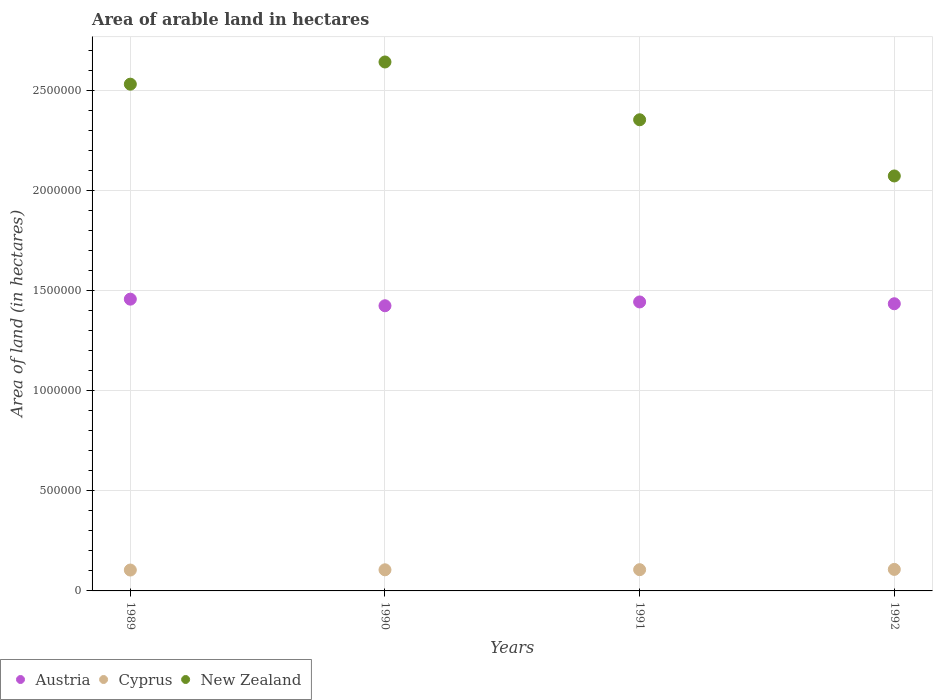What is the total arable land in New Zealand in 1990?
Provide a short and direct response. 2.64e+06. Across all years, what is the maximum total arable land in New Zealand?
Keep it short and to the point. 2.64e+06. Across all years, what is the minimum total arable land in Austria?
Your response must be concise. 1.43e+06. In which year was the total arable land in New Zealand minimum?
Your answer should be very brief. 1992. What is the total total arable land in New Zealand in the graph?
Keep it short and to the point. 9.61e+06. What is the difference between the total arable land in Cyprus in 1990 and that in 1991?
Your answer should be very brief. -600. What is the difference between the total arable land in Austria in 1992 and the total arable land in New Zealand in 1990?
Your response must be concise. -1.21e+06. What is the average total arable land in New Zealand per year?
Your answer should be compact. 2.40e+06. In the year 1991, what is the difference between the total arable land in Cyprus and total arable land in New Zealand?
Provide a succinct answer. -2.25e+06. What is the ratio of the total arable land in New Zealand in 1989 to that in 1990?
Make the answer very short. 0.96. Is the difference between the total arable land in Cyprus in 1991 and 1992 greater than the difference between the total arable land in New Zealand in 1991 and 1992?
Your response must be concise. No. What is the difference between the highest and the second highest total arable land in Austria?
Offer a terse response. 1.40e+04. What is the difference between the highest and the lowest total arable land in Cyprus?
Provide a short and direct response. 3200. In how many years, is the total arable land in Austria greater than the average total arable land in Austria taken over all years?
Offer a very short reply. 2. Is the sum of the total arable land in Cyprus in 1990 and 1992 greater than the maximum total arable land in Austria across all years?
Your answer should be very brief. No. Does the total arable land in Austria monotonically increase over the years?
Offer a very short reply. No. How many years are there in the graph?
Give a very brief answer. 4. Are the values on the major ticks of Y-axis written in scientific E-notation?
Provide a short and direct response. No. Does the graph contain grids?
Provide a succinct answer. Yes. Where does the legend appear in the graph?
Make the answer very short. Bottom left. What is the title of the graph?
Give a very brief answer. Area of arable land in hectares. What is the label or title of the X-axis?
Give a very brief answer. Years. What is the label or title of the Y-axis?
Provide a short and direct response. Area of land (in hectares). What is the Area of land (in hectares) in Austria in 1989?
Offer a terse response. 1.46e+06. What is the Area of land (in hectares) of Cyprus in 1989?
Offer a terse response. 1.04e+05. What is the Area of land (in hectares) of New Zealand in 1989?
Ensure brevity in your answer.  2.53e+06. What is the Area of land (in hectares) of Austria in 1990?
Provide a short and direct response. 1.43e+06. What is the Area of land (in hectares) in Cyprus in 1990?
Your answer should be compact. 1.06e+05. What is the Area of land (in hectares) of New Zealand in 1990?
Your answer should be compact. 2.64e+06. What is the Area of land (in hectares) of Austria in 1991?
Your answer should be compact. 1.44e+06. What is the Area of land (in hectares) in Cyprus in 1991?
Offer a very short reply. 1.06e+05. What is the Area of land (in hectares) in New Zealand in 1991?
Offer a terse response. 2.36e+06. What is the Area of land (in hectares) in Austria in 1992?
Provide a short and direct response. 1.44e+06. What is the Area of land (in hectares) of Cyprus in 1992?
Provide a short and direct response. 1.08e+05. What is the Area of land (in hectares) in New Zealand in 1992?
Make the answer very short. 2.08e+06. Across all years, what is the maximum Area of land (in hectares) of Austria?
Provide a short and direct response. 1.46e+06. Across all years, what is the maximum Area of land (in hectares) of Cyprus?
Your answer should be compact. 1.08e+05. Across all years, what is the maximum Area of land (in hectares) of New Zealand?
Offer a terse response. 2.64e+06. Across all years, what is the minimum Area of land (in hectares) of Austria?
Offer a very short reply. 1.43e+06. Across all years, what is the minimum Area of land (in hectares) of Cyprus?
Offer a very short reply. 1.04e+05. Across all years, what is the minimum Area of land (in hectares) in New Zealand?
Your response must be concise. 2.08e+06. What is the total Area of land (in hectares) in Austria in the graph?
Your answer should be compact. 5.77e+06. What is the total Area of land (in hectares) in Cyprus in the graph?
Provide a succinct answer. 4.24e+05. What is the total Area of land (in hectares) of New Zealand in the graph?
Your response must be concise. 9.61e+06. What is the difference between the Area of land (in hectares) of Austria in 1989 and that in 1990?
Provide a short and direct response. 3.30e+04. What is the difference between the Area of land (in hectares) in Cyprus in 1989 and that in 1990?
Provide a succinct answer. -1200. What is the difference between the Area of land (in hectares) of New Zealand in 1989 and that in 1990?
Your response must be concise. -1.11e+05. What is the difference between the Area of land (in hectares) in Austria in 1989 and that in 1991?
Keep it short and to the point. 1.40e+04. What is the difference between the Area of land (in hectares) in Cyprus in 1989 and that in 1991?
Your response must be concise. -1800. What is the difference between the Area of land (in hectares) of New Zealand in 1989 and that in 1991?
Your answer should be very brief. 1.78e+05. What is the difference between the Area of land (in hectares) of Austria in 1989 and that in 1992?
Make the answer very short. 2.30e+04. What is the difference between the Area of land (in hectares) in Cyprus in 1989 and that in 1992?
Your answer should be very brief. -3200. What is the difference between the Area of land (in hectares) of New Zealand in 1989 and that in 1992?
Provide a succinct answer. 4.59e+05. What is the difference between the Area of land (in hectares) of Austria in 1990 and that in 1991?
Your answer should be very brief. -1.90e+04. What is the difference between the Area of land (in hectares) of Cyprus in 1990 and that in 1991?
Your response must be concise. -600. What is the difference between the Area of land (in hectares) in New Zealand in 1990 and that in 1991?
Ensure brevity in your answer.  2.89e+05. What is the difference between the Area of land (in hectares) of Cyprus in 1990 and that in 1992?
Your answer should be compact. -2000. What is the difference between the Area of land (in hectares) of New Zealand in 1990 and that in 1992?
Ensure brevity in your answer.  5.70e+05. What is the difference between the Area of land (in hectares) of Austria in 1991 and that in 1992?
Keep it short and to the point. 9000. What is the difference between the Area of land (in hectares) in Cyprus in 1991 and that in 1992?
Give a very brief answer. -1400. What is the difference between the Area of land (in hectares) in New Zealand in 1991 and that in 1992?
Keep it short and to the point. 2.81e+05. What is the difference between the Area of land (in hectares) of Austria in 1989 and the Area of land (in hectares) of Cyprus in 1990?
Provide a succinct answer. 1.35e+06. What is the difference between the Area of land (in hectares) of Austria in 1989 and the Area of land (in hectares) of New Zealand in 1990?
Give a very brief answer. -1.19e+06. What is the difference between the Area of land (in hectares) of Cyprus in 1989 and the Area of land (in hectares) of New Zealand in 1990?
Your response must be concise. -2.54e+06. What is the difference between the Area of land (in hectares) of Austria in 1989 and the Area of land (in hectares) of Cyprus in 1991?
Keep it short and to the point. 1.35e+06. What is the difference between the Area of land (in hectares) of Austria in 1989 and the Area of land (in hectares) of New Zealand in 1991?
Your response must be concise. -8.97e+05. What is the difference between the Area of land (in hectares) of Cyprus in 1989 and the Area of land (in hectares) of New Zealand in 1991?
Offer a terse response. -2.25e+06. What is the difference between the Area of land (in hectares) in Austria in 1989 and the Area of land (in hectares) in Cyprus in 1992?
Give a very brief answer. 1.35e+06. What is the difference between the Area of land (in hectares) of Austria in 1989 and the Area of land (in hectares) of New Zealand in 1992?
Make the answer very short. -6.16e+05. What is the difference between the Area of land (in hectares) of Cyprus in 1989 and the Area of land (in hectares) of New Zealand in 1992?
Your answer should be very brief. -1.97e+06. What is the difference between the Area of land (in hectares) of Austria in 1990 and the Area of land (in hectares) of Cyprus in 1991?
Provide a succinct answer. 1.32e+06. What is the difference between the Area of land (in hectares) in Austria in 1990 and the Area of land (in hectares) in New Zealand in 1991?
Provide a short and direct response. -9.30e+05. What is the difference between the Area of land (in hectares) in Cyprus in 1990 and the Area of land (in hectares) in New Zealand in 1991?
Keep it short and to the point. -2.25e+06. What is the difference between the Area of land (in hectares) of Austria in 1990 and the Area of land (in hectares) of Cyprus in 1992?
Offer a terse response. 1.32e+06. What is the difference between the Area of land (in hectares) in Austria in 1990 and the Area of land (in hectares) in New Zealand in 1992?
Keep it short and to the point. -6.49e+05. What is the difference between the Area of land (in hectares) of Cyprus in 1990 and the Area of land (in hectares) of New Zealand in 1992?
Your answer should be compact. -1.97e+06. What is the difference between the Area of land (in hectares) in Austria in 1991 and the Area of land (in hectares) in Cyprus in 1992?
Your response must be concise. 1.34e+06. What is the difference between the Area of land (in hectares) in Austria in 1991 and the Area of land (in hectares) in New Zealand in 1992?
Your answer should be compact. -6.30e+05. What is the difference between the Area of land (in hectares) in Cyprus in 1991 and the Area of land (in hectares) in New Zealand in 1992?
Offer a very short reply. -1.97e+06. What is the average Area of land (in hectares) of Austria per year?
Your response must be concise. 1.44e+06. What is the average Area of land (in hectares) in Cyprus per year?
Give a very brief answer. 1.06e+05. What is the average Area of land (in hectares) in New Zealand per year?
Offer a very short reply. 2.40e+06. In the year 1989, what is the difference between the Area of land (in hectares) in Austria and Area of land (in hectares) in Cyprus?
Provide a succinct answer. 1.35e+06. In the year 1989, what is the difference between the Area of land (in hectares) in Austria and Area of land (in hectares) in New Zealand?
Keep it short and to the point. -1.08e+06. In the year 1989, what is the difference between the Area of land (in hectares) of Cyprus and Area of land (in hectares) of New Zealand?
Give a very brief answer. -2.43e+06. In the year 1990, what is the difference between the Area of land (in hectares) in Austria and Area of land (in hectares) in Cyprus?
Offer a terse response. 1.32e+06. In the year 1990, what is the difference between the Area of land (in hectares) of Austria and Area of land (in hectares) of New Zealand?
Your response must be concise. -1.22e+06. In the year 1990, what is the difference between the Area of land (in hectares) of Cyprus and Area of land (in hectares) of New Zealand?
Make the answer very short. -2.54e+06. In the year 1991, what is the difference between the Area of land (in hectares) of Austria and Area of land (in hectares) of Cyprus?
Keep it short and to the point. 1.34e+06. In the year 1991, what is the difference between the Area of land (in hectares) of Austria and Area of land (in hectares) of New Zealand?
Offer a terse response. -9.11e+05. In the year 1991, what is the difference between the Area of land (in hectares) in Cyprus and Area of land (in hectares) in New Zealand?
Ensure brevity in your answer.  -2.25e+06. In the year 1992, what is the difference between the Area of land (in hectares) in Austria and Area of land (in hectares) in Cyprus?
Provide a short and direct response. 1.33e+06. In the year 1992, what is the difference between the Area of land (in hectares) of Austria and Area of land (in hectares) of New Zealand?
Your answer should be compact. -6.39e+05. In the year 1992, what is the difference between the Area of land (in hectares) in Cyprus and Area of land (in hectares) in New Zealand?
Make the answer very short. -1.97e+06. What is the ratio of the Area of land (in hectares) in Austria in 1989 to that in 1990?
Make the answer very short. 1.02. What is the ratio of the Area of land (in hectares) of New Zealand in 1989 to that in 1990?
Provide a short and direct response. 0.96. What is the ratio of the Area of land (in hectares) in Austria in 1989 to that in 1991?
Keep it short and to the point. 1.01. What is the ratio of the Area of land (in hectares) in Cyprus in 1989 to that in 1991?
Provide a short and direct response. 0.98. What is the ratio of the Area of land (in hectares) of New Zealand in 1989 to that in 1991?
Keep it short and to the point. 1.08. What is the ratio of the Area of land (in hectares) of Austria in 1989 to that in 1992?
Ensure brevity in your answer.  1.02. What is the ratio of the Area of land (in hectares) in Cyprus in 1989 to that in 1992?
Offer a terse response. 0.97. What is the ratio of the Area of land (in hectares) of New Zealand in 1989 to that in 1992?
Offer a very short reply. 1.22. What is the ratio of the Area of land (in hectares) of Austria in 1990 to that in 1991?
Make the answer very short. 0.99. What is the ratio of the Area of land (in hectares) in Cyprus in 1990 to that in 1991?
Make the answer very short. 0.99. What is the ratio of the Area of land (in hectares) in New Zealand in 1990 to that in 1991?
Your response must be concise. 1.12. What is the ratio of the Area of land (in hectares) in Austria in 1990 to that in 1992?
Ensure brevity in your answer.  0.99. What is the ratio of the Area of land (in hectares) in Cyprus in 1990 to that in 1992?
Your answer should be compact. 0.98. What is the ratio of the Area of land (in hectares) in New Zealand in 1990 to that in 1992?
Your response must be concise. 1.27. What is the ratio of the Area of land (in hectares) of Austria in 1991 to that in 1992?
Your answer should be very brief. 1.01. What is the ratio of the Area of land (in hectares) in New Zealand in 1991 to that in 1992?
Your answer should be compact. 1.14. What is the difference between the highest and the second highest Area of land (in hectares) in Austria?
Offer a very short reply. 1.40e+04. What is the difference between the highest and the second highest Area of land (in hectares) of Cyprus?
Give a very brief answer. 1400. What is the difference between the highest and the second highest Area of land (in hectares) of New Zealand?
Your answer should be compact. 1.11e+05. What is the difference between the highest and the lowest Area of land (in hectares) in Austria?
Offer a very short reply. 3.30e+04. What is the difference between the highest and the lowest Area of land (in hectares) of Cyprus?
Your answer should be compact. 3200. What is the difference between the highest and the lowest Area of land (in hectares) in New Zealand?
Your answer should be very brief. 5.70e+05. 